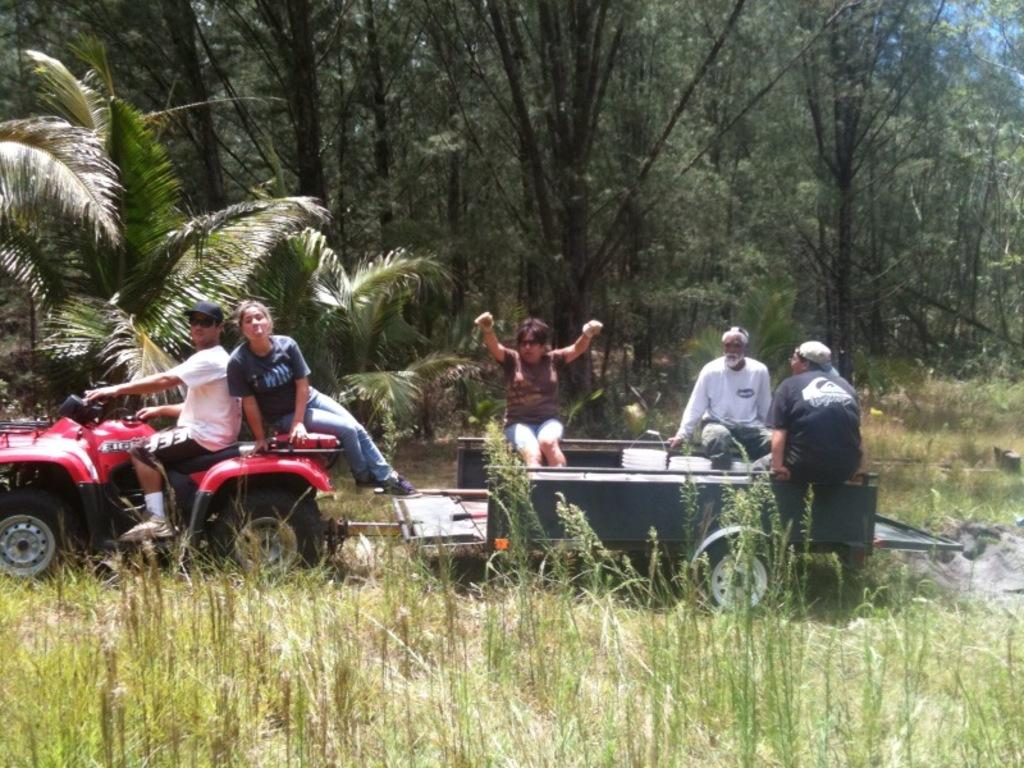What are the people in the image doing? The people in the image are sitting on a tractor. Who is operating the tractor? There is a person riding the tractor. What can be seen in the background of the image? Trees are visible in the background of the image. What type of ray is swimming in the background of the image? There are no rays present in the image; it features people sitting on a tractor with trees in the background. 